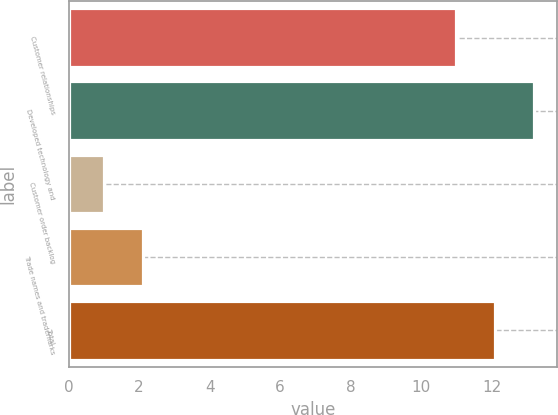Convert chart to OTSL. <chart><loc_0><loc_0><loc_500><loc_500><bar_chart><fcel>Customer relationships<fcel>Developed technology and<fcel>Customer order backlog<fcel>Trade names and trademarks<fcel>Total<nl><fcel>11<fcel>13.2<fcel>1<fcel>2.1<fcel>12.1<nl></chart> 